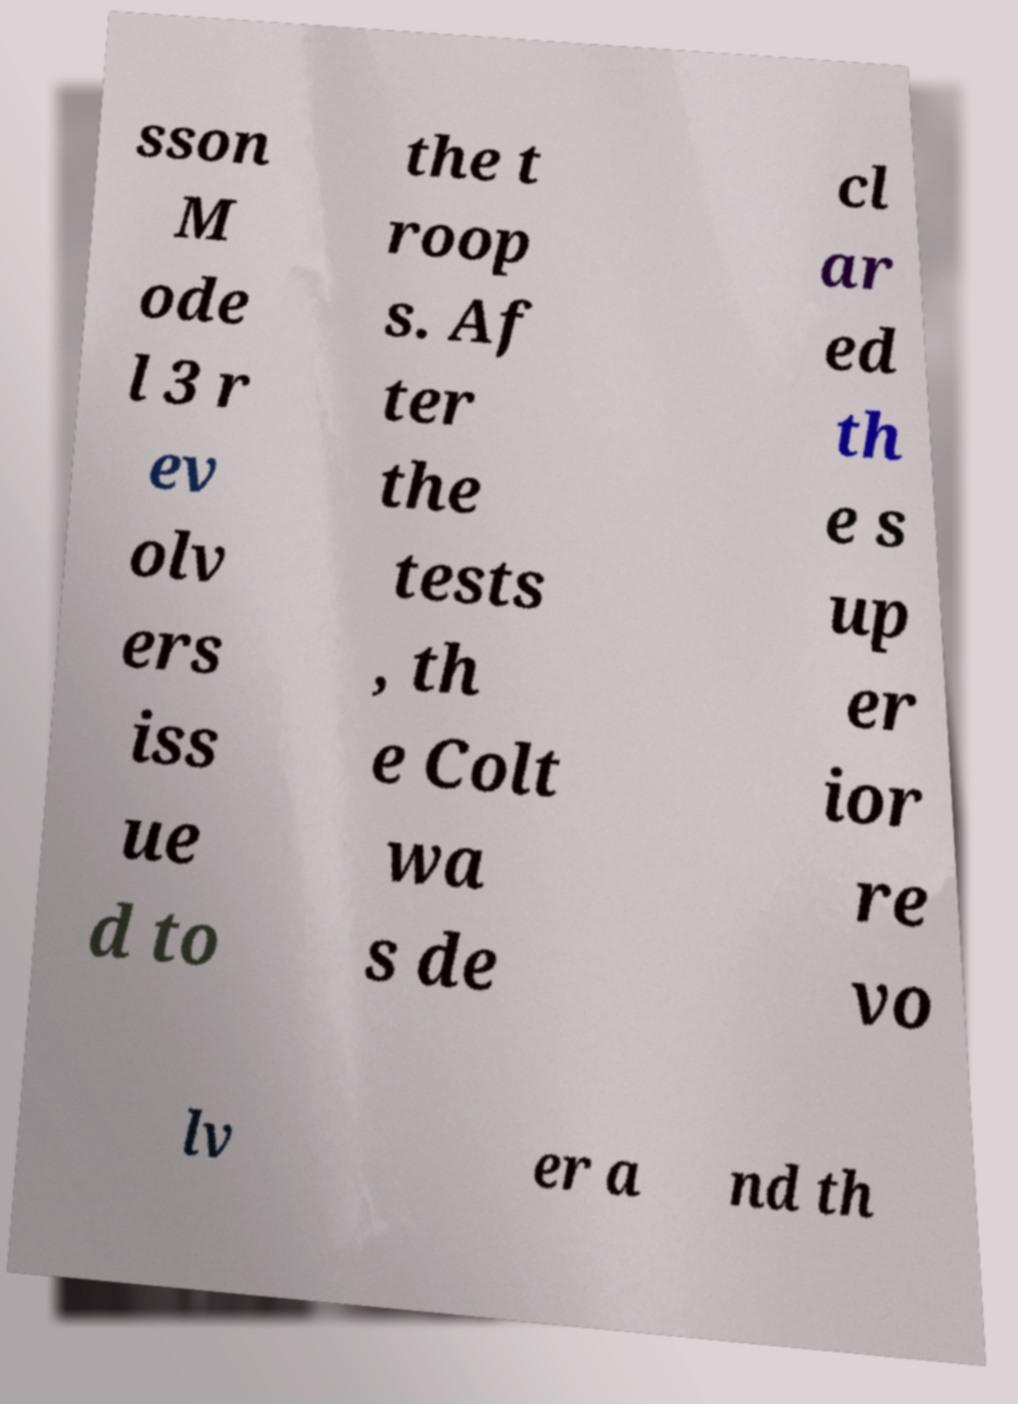Can you accurately transcribe the text from the provided image for me? sson M ode l 3 r ev olv ers iss ue d to the t roop s. Af ter the tests , th e Colt wa s de cl ar ed th e s up er ior re vo lv er a nd th 